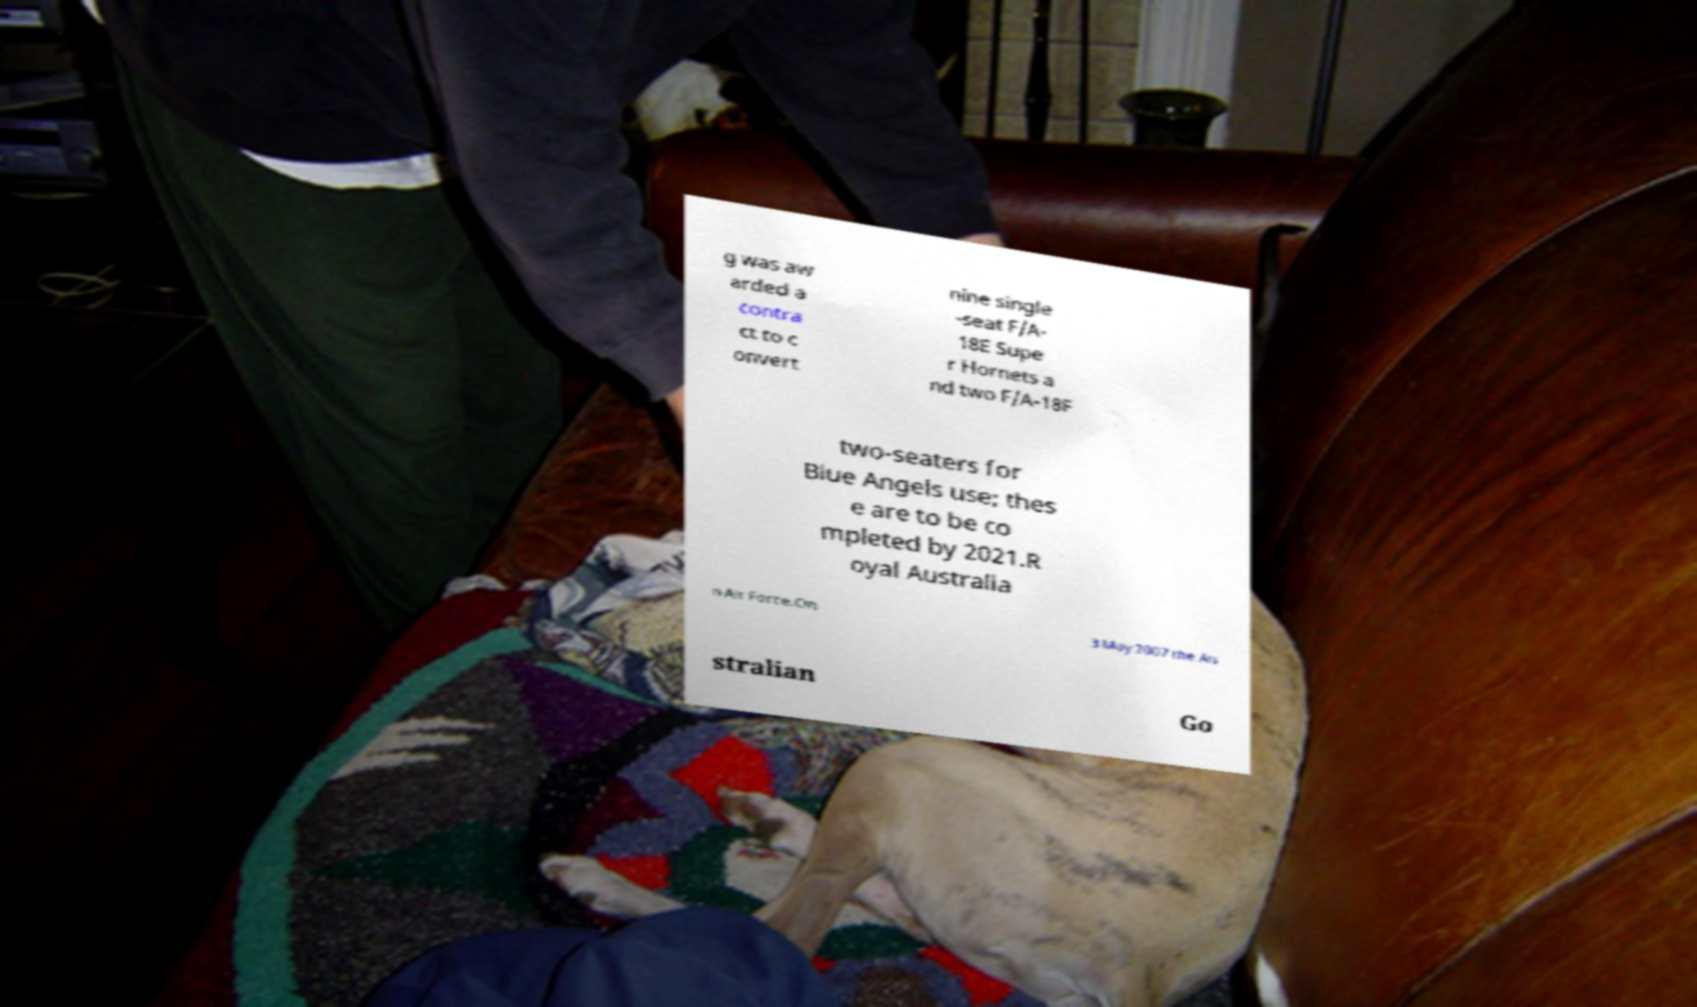Could you assist in decoding the text presented in this image and type it out clearly? g was aw arded a contra ct to c onvert nine single -seat F/A- 18E Supe r Hornets a nd two F/A-18F two-seaters for Blue Angels use; thes e are to be co mpleted by 2021.R oyal Australia n Air Force.On 3 May 2007 the Au stralian Go 